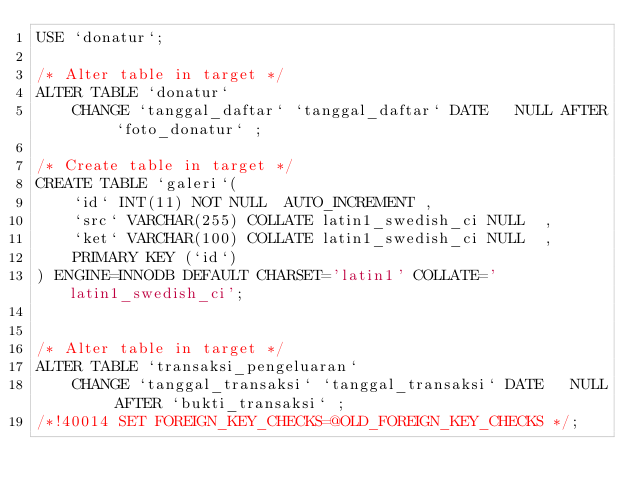Convert code to text. <code><loc_0><loc_0><loc_500><loc_500><_SQL_>USE `donatur`;

/* Alter table in target */
ALTER TABLE `donatur` 
	CHANGE `tanggal_daftar` `tanggal_daftar` DATE   NULL AFTER `foto_donatur` ;

/* Create table in target */
CREATE TABLE `galeri`(
	`id` INT(11) NOT NULL  AUTO_INCREMENT , 
	`src` VARCHAR(255) COLLATE latin1_swedish_ci NULL  , 
	`ket` VARCHAR(100) COLLATE latin1_swedish_ci NULL  , 
	PRIMARY KEY (`id`) 
) ENGINE=INNODB DEFAULT CHARSET='latin1' COLLATE='latin1_swedish_ci';


/* Alter table in target */
ALTER TABLE `transaksi_pengeluaran` 
	CHANGE `tanggal_transaksi` `tanggal_transaksi` DATE   NULL AFTER `bukti_transaksi` ;
/*!40014 SET FOREIGN_KEY_CHECKS=@OLD_FOREIGN_KEY_CHECKS */;</code> 